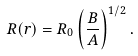<formula> <loc_0><loc_0><loc_500><loc_500>R ( r ) = R _ { 0 } \left ( \frac { B } { A } \right ) ^ { 1 / 2 } .</formula> 